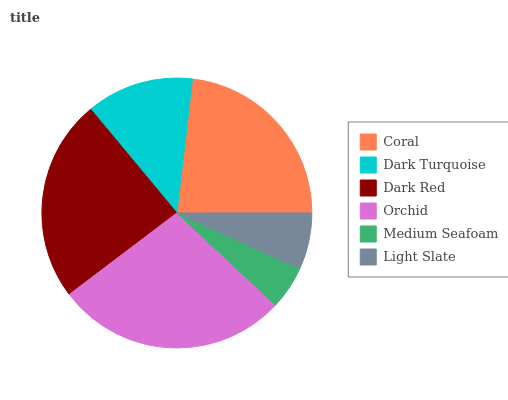Is Medium Seafoam the minimum?
Answer yes or no. Yes. Is Orchid the maximum?
Answer yes or no. Yes. Is Dark Turquoise the minimum?
Answer yes or no. No. Is Dark Turquoise the maximum?
Answer yes or no. No. Is Coral greater than Dark Turquoise?
Answer yes or no. Yes. Is Dark Turquoise less than Coral?
Answer yes or no. Yes. Is Dark Turquoise greater than Coral?
Answer yes or no. No. Is Coral less than Dark Turquoise?
Answer yes or no. No. Is Coral the high median?
Answer yes or no. Yes. Is Dark Turquoise the low median?
Answer yes or no. Yes. Is Medium Seafoam the high median?
Answer yes or no. No. Is Coral the low median?
Answer yes or no. No. 